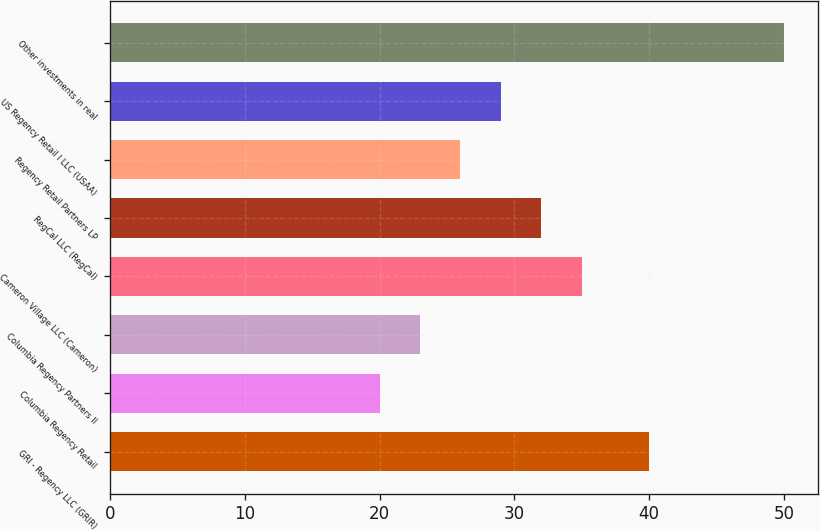Convert chart to OTSL. <chart><loc_0><loc_0><loc_500><loc_500><bar_chart><fcel>GRI - Regency LLC (GRIR)<fcel>Columbia Regency Retail<fcel>Columbia Regency Partners II<fcel>Cameron Village LLC (Cameron)<fcel>RegCal LLC (RegCal)<fcel>Regency Retail Partners LP<fcel>US Regency Retail I LLC (USAA)<fcel>Other investments in real<nl><fcel>40<fcel>20<fcel>23<fcel>35<fcel>32<fcel>26<fcel>29<fcel>50<nl></chart> 